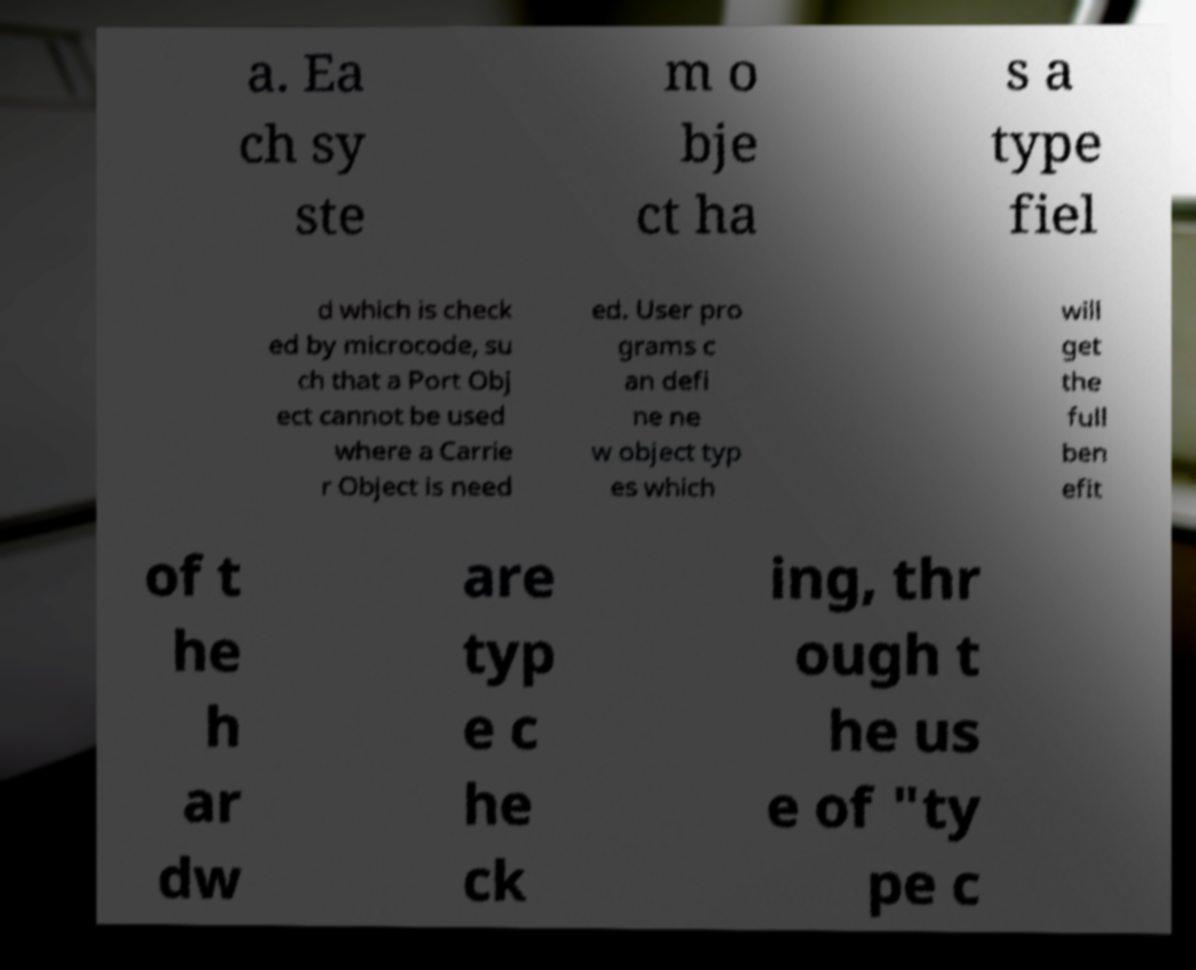Please read and relay the text visible in this image. What does it say? a. Ea ch sy ste m o bje ct ha s a type fiel d which is check ed by microcode, su ch that a Port Obj ect cannot be used where a Carrie r Object is need ed. User pro grams c an defi ne ne w object typ es which will get the full ben efit of t he h ar dw are typ e c he ck ing, thr ough t he us e of "ty pe c 